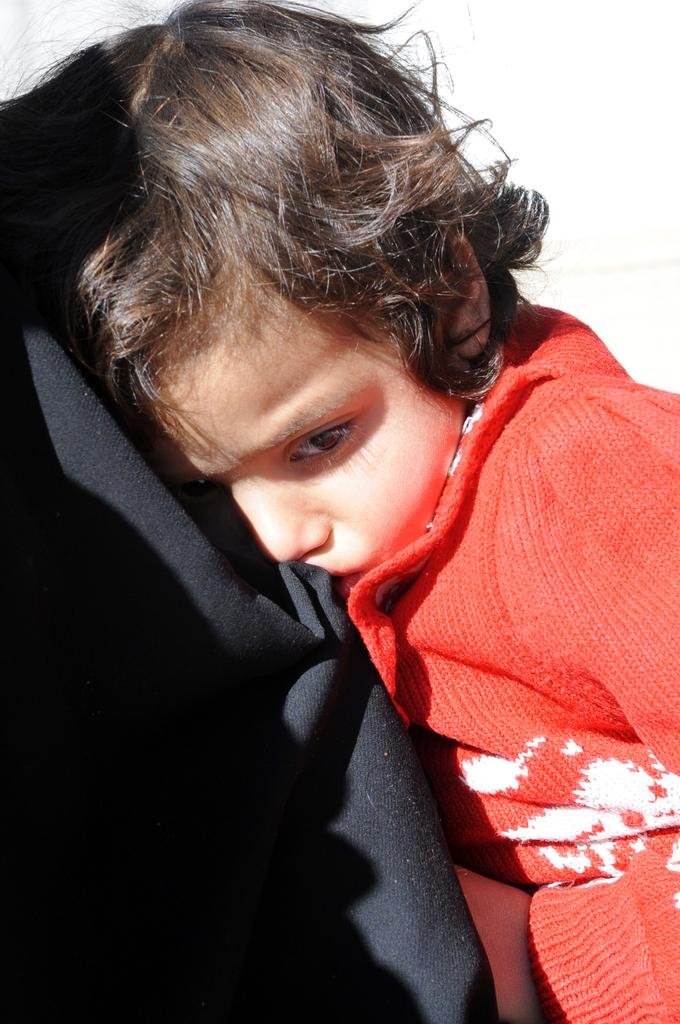What is the main subject of the image? The main subject of the image is a kid. What is the kid sitting or lying on? The kid is on a black cloth. What color is the background of the image? The background of the image is white. Where is the nearest market to the location of the image? The provided facts do not mention a market or its location, so it cannot be determined from the image. 